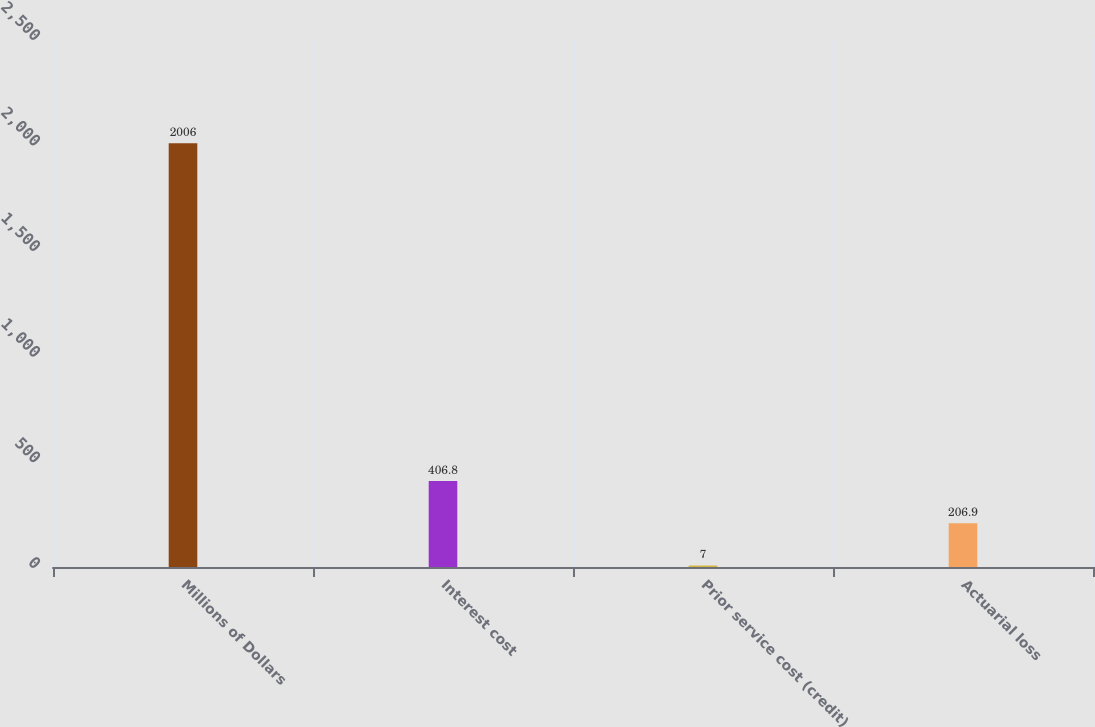<chart> <loc_0><loc_0><loc_500><loc_500><bar_chart><fcel>Millions of Dollars<fcel>Interest cost<fcel>Prior service cost (credit)<fcel>Actuarial loss<nl><fcel>2006<fcel>406.8<fcel>7<fcel>206.9<nl></chart> 